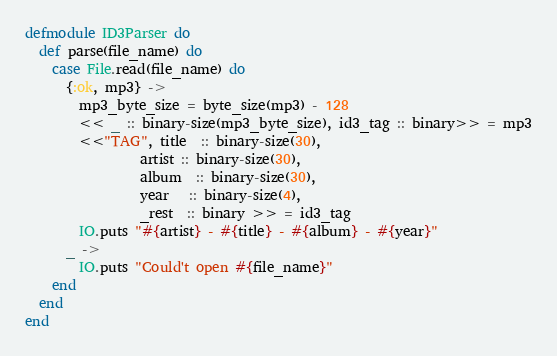<code> <loc_0><loc_0><loc_500><loc_500><_Elixir_>defmodule ID3Parser do
  def parse(file_name) do
    case File.read(file_name) do
      {:ok, mp3} ->
        mp3_byte_size = byte_size(mp3) - 128
        << _ :: binary-size(mp3_byte_size), id3_tag :: binary>> = mp3
        <<"TAG", title  :: binary-size(30),
                 artist :: binary-size(30),
                 album  :: binary-size(30),
                 year   :: binary-size(4),
                 _rest  :: binary >> = id3_tag
        IO.puts "#{artist} - #{title} - #{album} - #{year}"
      _ ->
        IO.puts "Could't open #{file_name}"
    end
  end
end

</code> 